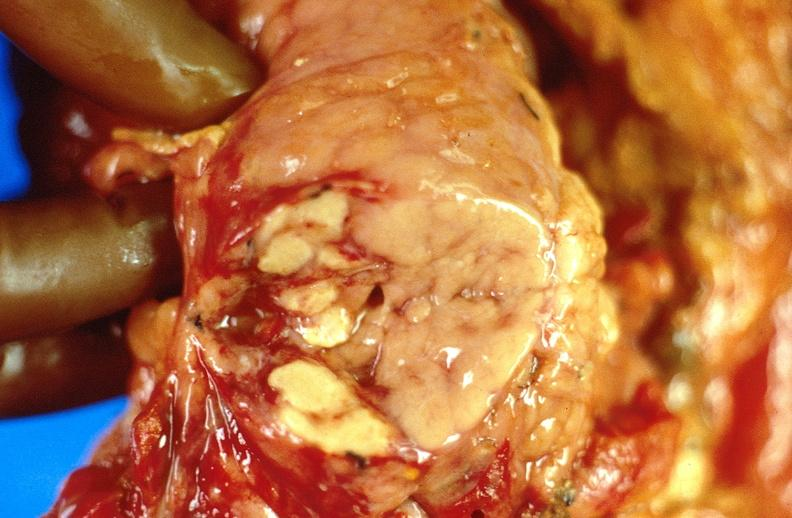what does this image show?
Answer the question using a single word or phrase. Pancreatic fat necrosis 